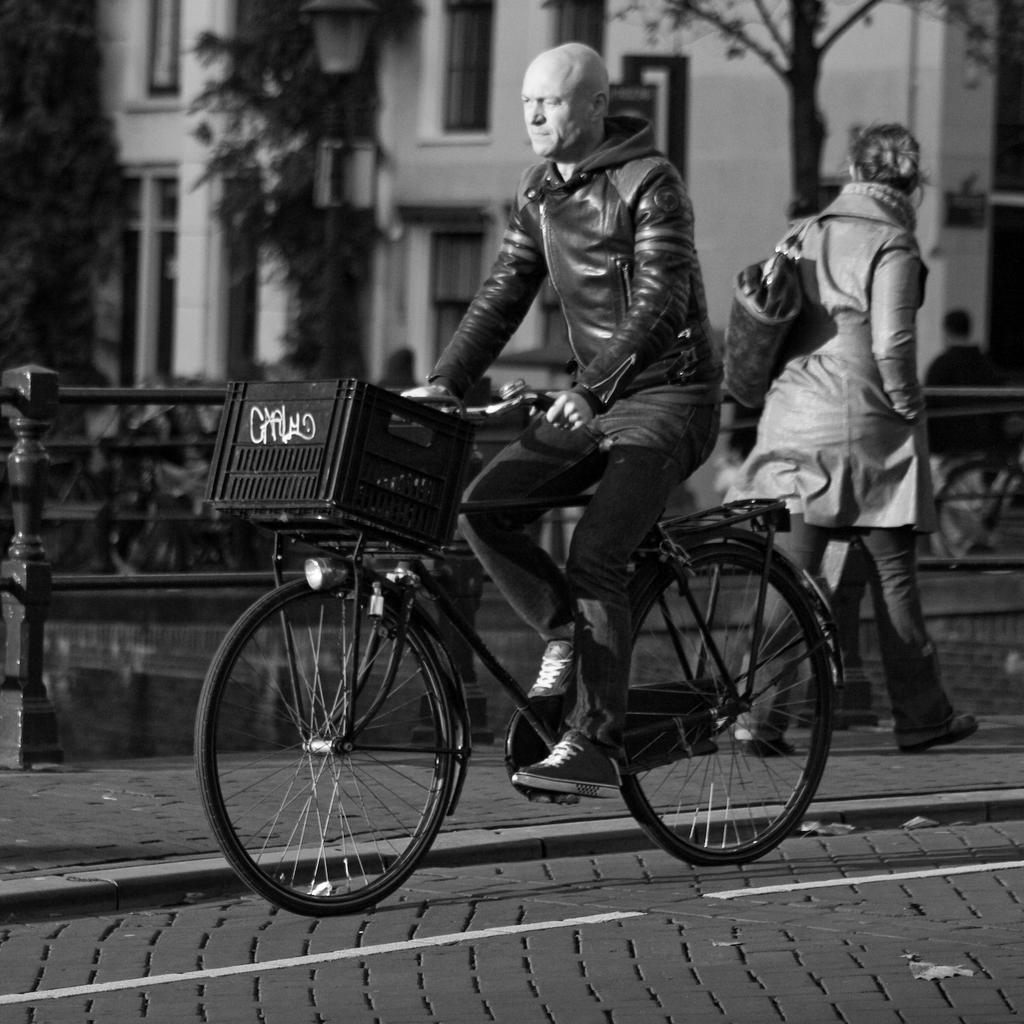How would you summarize this image in a sentence or two? In the image we can see there is a man who is riding bicycle on the road and there is a woman who is standing on the road and at the back there is a building and trees and the image is in black and white colour. 